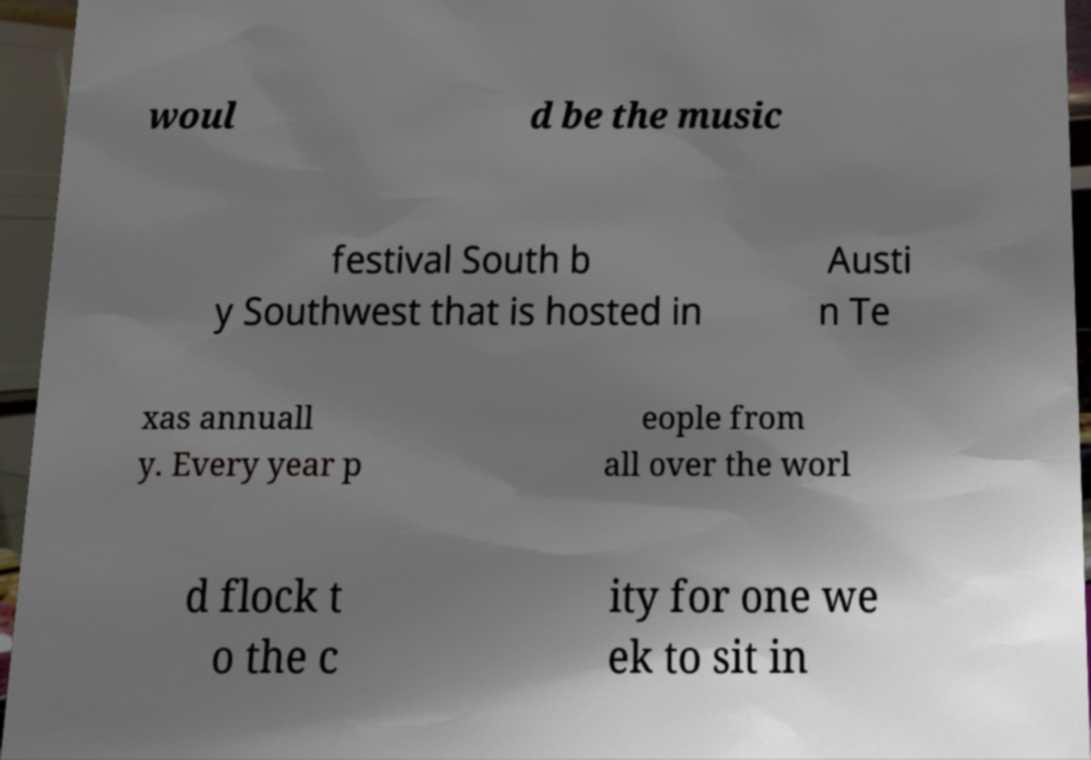Can you accurately transcribe the text from the provided image for me? woul d be the music festival South b y Southwest that is hosted in Austi n Te xas annuall y. Every year p eople from all over the worl d flock t o the c ity for one we ek to sit in 